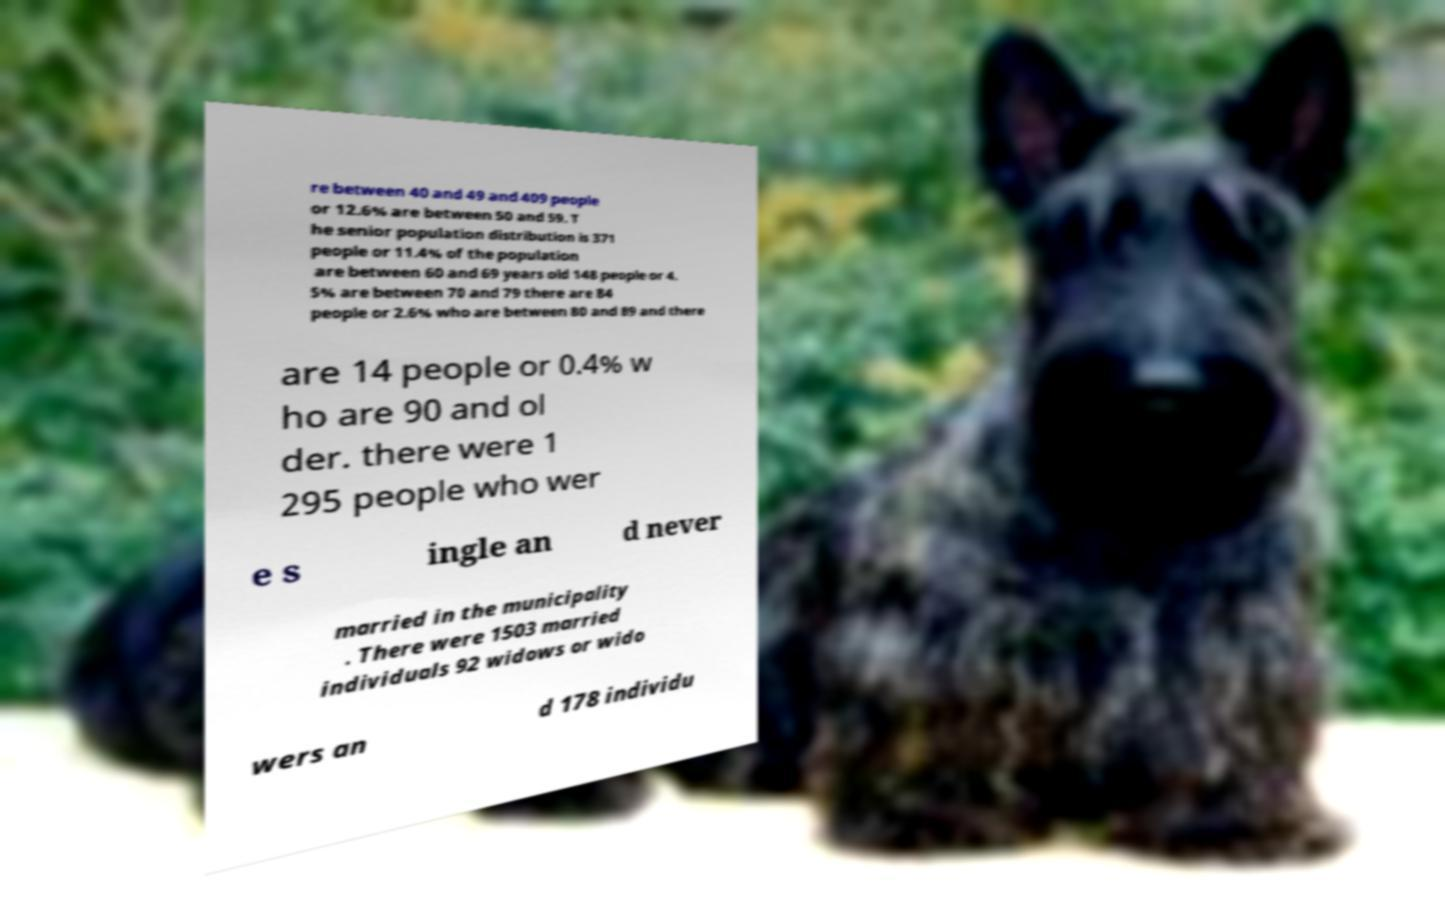For documentation purposes, I need the text within this image transcribed. Could you provide that? re between 40 and 49 and 409 people or 12.6% are between 50 and 59. T he senior population distribution is 371 people or 11.4% of the population are between 60 and 69 years old 148 people or 4. 5% are between 70 and 79 there are 84 people or 2.6% who are between 80 and 89 and there are 14 people or 0.4% w ho are 90 and ol der. there were 1 295 people who wer e s ingle an d never married in the municipality . There were 1503 married individuals 92 widows or wido wers an d 178 individu 